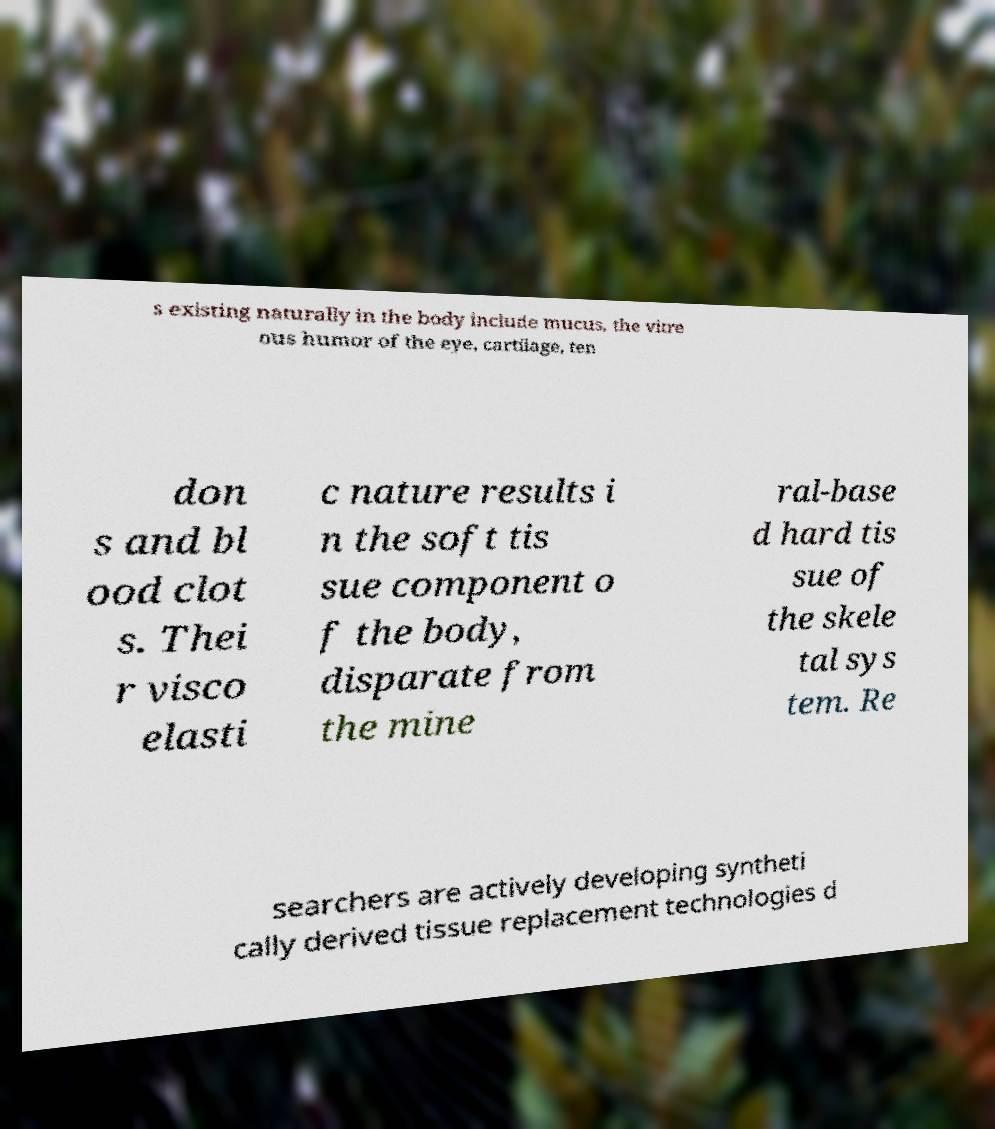Could you assist in decoding the text presented in this image and type it out clearly? s existing naturally in the body include mucus, the vitre ous humor of the eye, cartilage, ten don s and bl ood clot s. Thei r visco elasti c nature results i n the soft tis sue component o f the body, disparate from the mine ral-base d hard tis sue of the skele tal sys tem. Re searchers are actively developing syntheti cally derived tissue replacement technologies d 